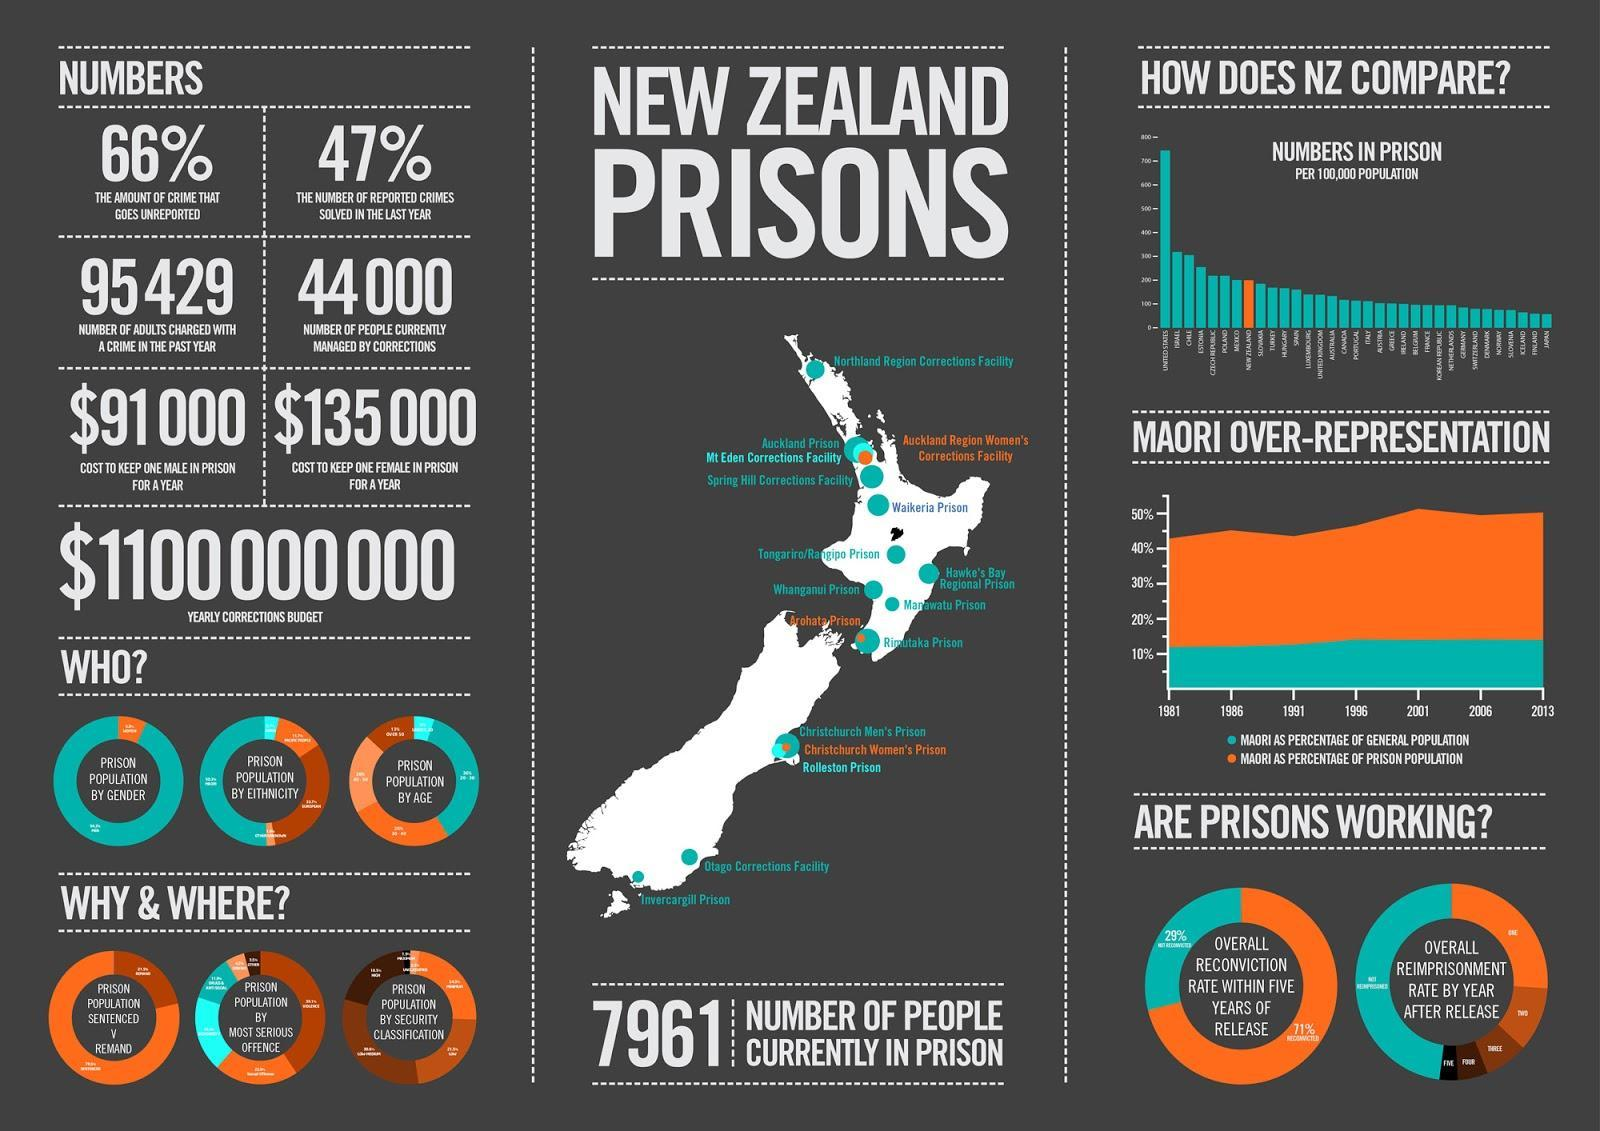What is the additional cost incurred to New Zealand government in providing for a female prisoner?
Answer the question with a short phrase. $44,000 How many women's prisons are there in New Zealand? 3 What is the global ranking of New Zealand in terms of the numbers in prison? 8 